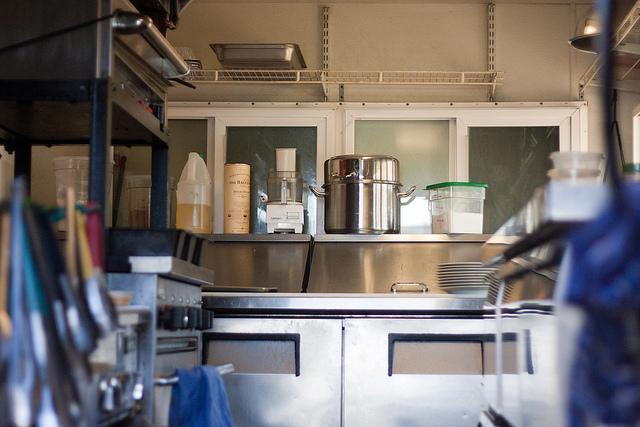Is this an industrial type kitchen?
Write a very short answer. Yes. Where is a jug of grease?
Short answer required. On shelf. Is there a towel hanging on the equipment?
Quick response, please. Yes. 